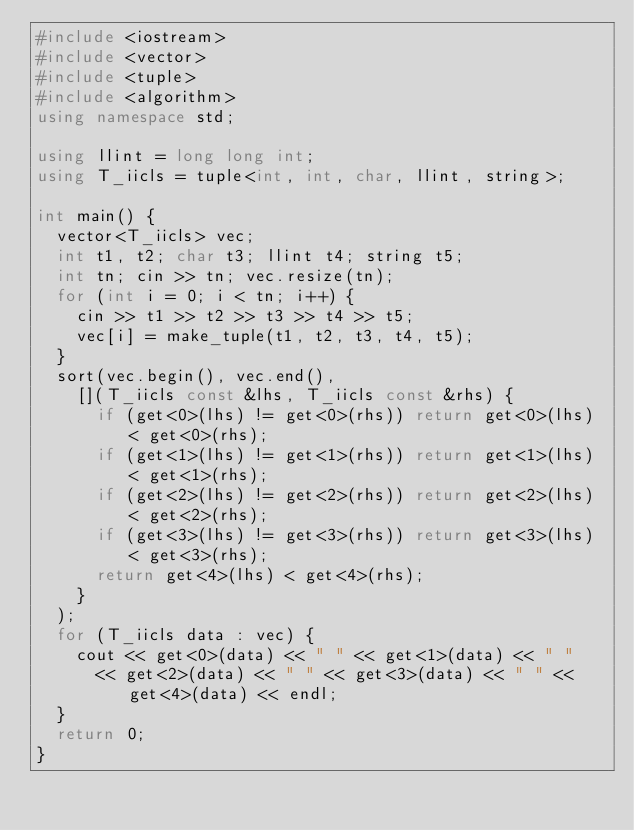Convert code to text. <code><loc_0><loc_0><loc_500><loc_500><_C++_>#include <iostream>
#include <vector>
#include <tuple>
#include <algorithm>
using namespace std;

using llint = long long int;
using T_iicls = tuple<int, int, char, llint, string>;

int main() {
	vector<T_iicls> vec;
	int t1, t2; char t3; llint t4; string t5;
	int tn; cin >> tn; vec.resize(tn);
	for (int i = 0; i < tn; i++) {
		cin >> t1 >> t2 >> t3 >> t4 >> t5;
		vec[i] = make_tuple(t1, t2, t3, t4, t5);
	}
	sort(vec.begin(), vec.end(),
		[](T_iicls const &lhs, T_iicls const &rhs) {
			if (get<0>(lhs) != get<0>(rhs)) return get<0>(lhs) < get<0>(rhs);
			if (get<1>(lhs) != get<1>(rhs)) return get<1>(lhs) < get<1>(rhs);
			if (get<2>(lhs) != get<2>(rhs)) return get<2>(lhs) < get<2>(rhs);
			if (get<3>(lhs) != get<3>(rhs)) return get<3>(lhs) < get<3>(rhs);
			return get<4>(lhs) < get<4>(rhs);
		}
	);
	for (T_iicls data : vec) {
		cout << get<0>(data) << " " << get<1>(data) << " " 
			<< get<2>(data) << " " << get<3>(data) << " " << get<4>(data) << endl;
	}
	return 0;
}
</code> 